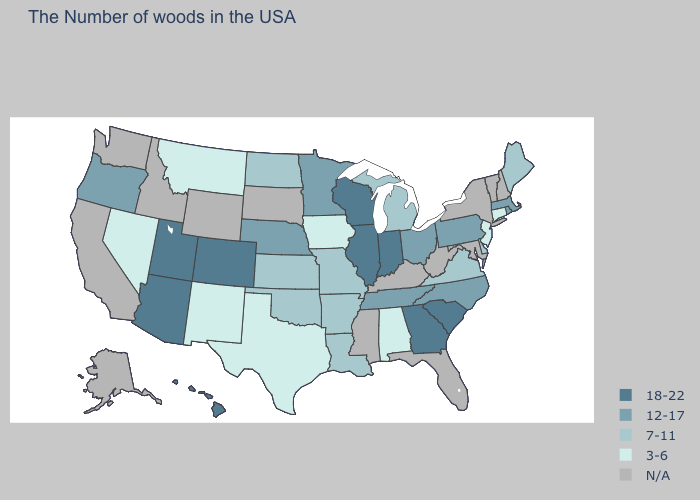Does Oregon have the highest value in the West?
Quick response, please. No. How many symbols are there in the legend?
Be succinct. 5. What is the value of Wyoming?
Answer briefly. N/A. What is the highest value in the MidWest ?
Keep it brief. 18-22. Name the states that have a value in the range 7-11?
Quick response, please. Maine, Delaware, Virginia, Michigan, Louisiana, Missouri, Arkansas, Kansas, Oklahoma, North Dakota. Does New Jersey have the highest value in the USA?
Be succinct. No. What is the value of Ohio?
Keep it brief. 12-17. Name the states that have a value in the range 12-17?
Give a very brief answer. Massachusetts, Rhode Island, Pennsylvania, North Carolina, Ohio, Tennessee, Minnesota, Nebraska, Oregon. Name the states that have a value in the range 3-6?
Give a very brief answer. Connecticut, New Jersey, Alabama, Iowa, Texas, New Mexico, Montana, Nevada. Name the states that have a value in the range 12-17?
Answer briefly. Massachusetts, Rhode Island, Pennsylvania, North Carolina, Ohio, Tennessee, Minnesota, Nebraska, Oregon. Does Montana have the highest value in the USA?
Be succinct. No. Among the states that border Michigan , which have the lowest value?
Concise answer only. Ohio. What is the value of Wisconsin?
Write a very short answer. 18-22. Which states have the lowest value in the MidWest?
Keep it brief. Iowa. 